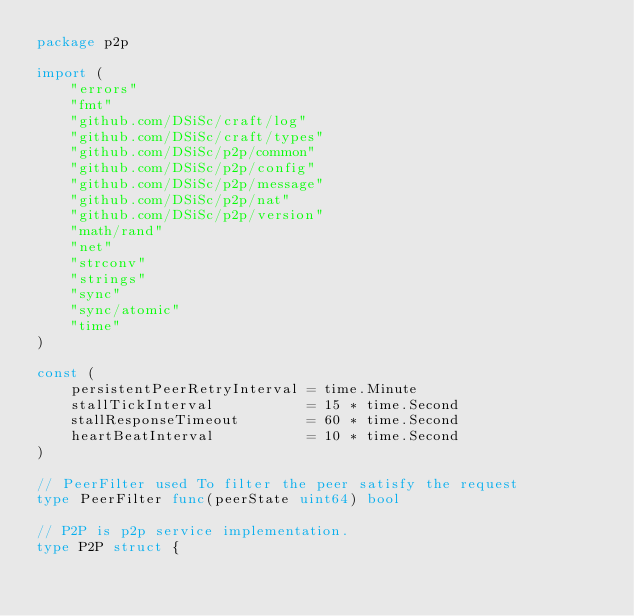<code> <loc_0><loc_0><loc_500><loc_500><_Go_>package p2p

import (
	"errors"
	"fmt"
	"github.com/DSiSc/craft/log"
	"github.com/DSiSc/craft/types"
	"github.com/DSiSc/p2p/common"
	"github.com/DSiSc/p2p/config"
	"github.com/DSiSc/p2p/message"
	"github.com/DSiSc/p2p/nat"
	"github.com/DSiSc/p2p/version"
	"math/rand"
	"net"
	"strconv"
	"strings"
	"sync"
	"sync/atomic"
	"time"
)

const (
	persistentPeerRetryInterval = time.Minute
	stallTickInterval           = 15 * time.Second
	stallResponseTimeout        = 60 * time.Second
	heartBeatInterval           = 10 * time.Second
)

// PeerFilter used To filter the peer satisfy the request
type PeerFilter func(peerState uint64) bool

// P2P is p2p service implementation.
type P2P struct {</code> 